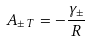<formula> <loc_0><loc_0><loc_500><loc_500>A _ { \pm \, T } = - \frac { \gamma _ { \pm } } { R }</formula> 